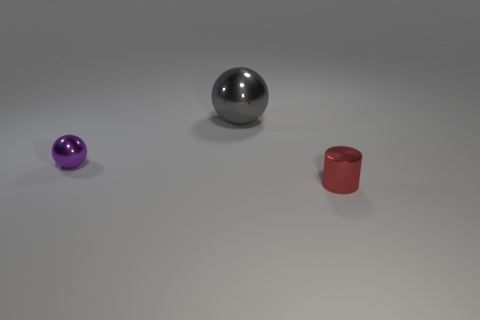Is the number of purple shiny objects that are to the left of the cylinder greater than the number of tiny purple objects that are to the right of the gray ball?
Provide a succinct answer. Yes. There is a red metallic thing; is its size the same as the sphere to the right of the tiny purple ball?
Offer a very short reply. No. How many cubes are tiny purple metal things or tiny shiny objects?
Keep it short and to the point. 0. What size is the red cylinder that is made of the same material as the tiny ball?
Give a very brief answer. Small. Do the red cylinder right of the purple ball and the metal thing to the left of the gray object have the same size?
Your answer should be compact. Yes. What number of things are either tiny metal cylinders or big metallic balls?
Make the answer very short. 2. The gray metal thing is what shape?
Your response must be concise. Sphere. What size is the purple metallic object that is the same shape as the large gray metal thing?
Give a very brief answer. Small. Are there any other things that have the same material as the small purple thing?
Offer a very short reply. Yes. What size is the shiny sphere that is in front of the metallic ball that is behind the small shiny sphere?
Provide a succinct answer. Small. 